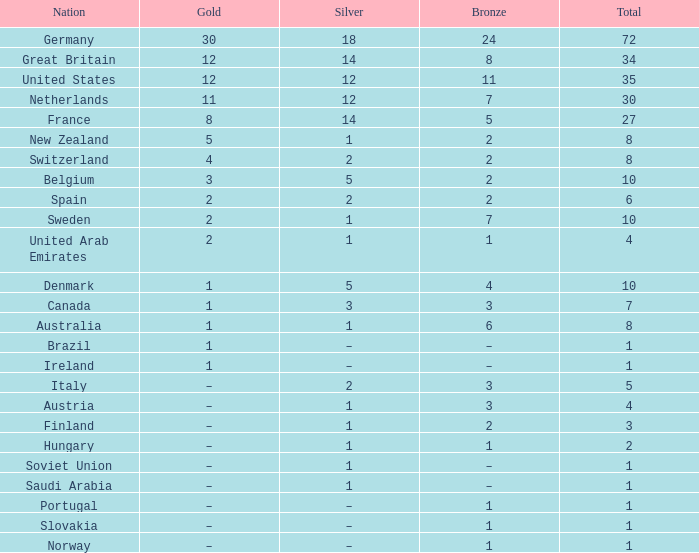If silver equals 2 and the country in question is italy, what can be deduced about bronze? 3.0. 